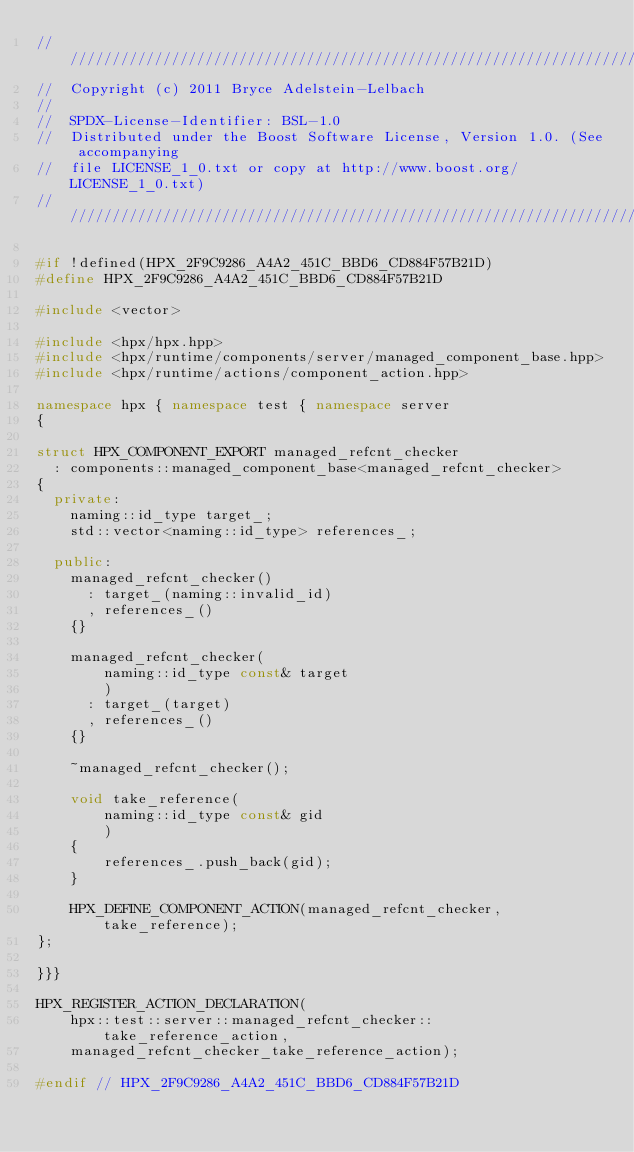Convert code to text. <code><loc_0><loc_0><loc_500><loc_500><_C++_>////////////////////////////////////////////////////////////////////////////////
//  Copyright (c) 2011 Bryce Adelstein-Lelbach
//
//  SPDX-License-Identifier: BSL-1.0
//  Distributed under the Boost Software License, Version 1.0. (See accompanying
//  file LICENSE_1_0.txt or copy at http://www.boost.org/LICENSE_1_0.txt)
////////////////////////////////////////////////////////////////////////////////

#if !defined(HPX_2F9C9286_A4A2_451C_BBD6_CD884F57B21D)
#define HPX_2F9C9286_A4A2_451C_BBD6_CD884F57B21D

#include <vector>

#include <hpx/hpx.hpp>
#include <hpx/runtime/components/server/managed_component_base.hpp>
#include <hpx/runtime/actions/component_action.hpp>

namespace hpx { namespace test { namespace server
{

struct HPX_COMPONENT_EXPORT managed_refcnt_checker
  : components::managed_component_base<managed_refcnt_checker>
{
  private:
    naming::id_type target_;
    std::vector<naming::id_type> references_;

  public:
    managed_refcnt_checker()
      : target_(naming::invalid_id)
      , references_()
    {}

    managed_refcnt_checker(
        naming::id_type const& target
        )
      : target_(target)
      , references_()
    {}

    ~managed_refcnt_checker();

    void take_reference(
        naming::id_type const& gid
        )
    {
        references_.push_back(gid);
    }

    HPX_DEFINE_COMPONENT_ACTION(managed_refcnt_checker, take_reference);
};

}}}

HPX_REGISTER_ACTION_DECLARATION(
    hpx::test::server::managed_refcnt_checker::take_reference_action,
    managed_refcnt_checker_take_reference_action);

#endif // HPX_2F9C9286_A4A2_451C_BBD6_CD884F57B21D

</code> 